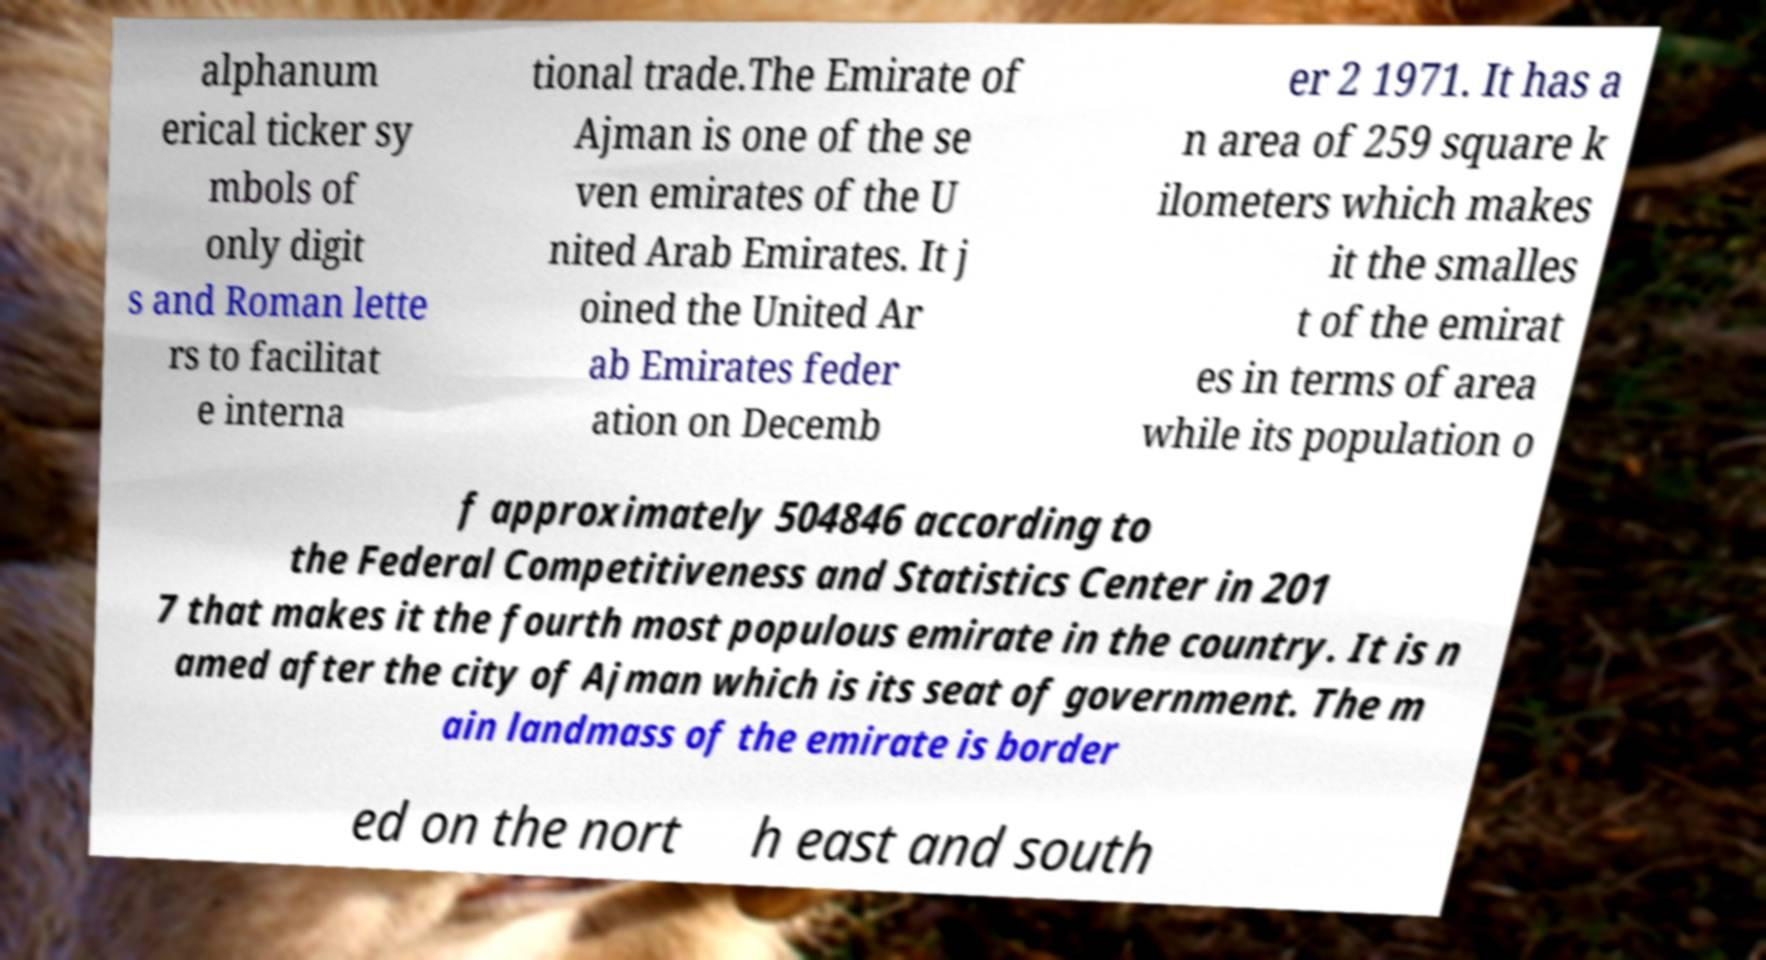What messages or text are displayed in this image? I need them in a readable, typed format. alphanum erical ticker sy mbols of only digit s and Roman lette rs to facilitat e interna tional trade.The Emirate of Ajman is one of the se ven emirates of the U nited Arab Emirates. It j oined the United Ar ab Emirates feder ation on Decemb er 2 1971. It has a n area of 259 square k ilometers which makes it the smalles t of the emirat es in terms of area while its population o f approximately 504846 according to the Federal Competitiveness and Statistics Center in 201 7 that makes it the fourth most populous emirate in the country. It is n amed after the city of Ajman which is its seat of government. The m ain landmass of the emirate is border ed on the nort h east and south 